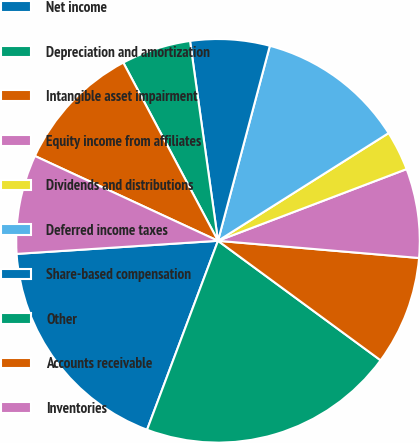<chart> <loc_0><loc_0><loc_500><loc_500><pie_chart><fcel>Net income<fcel>Depreciation and amortization<fcel>Intangible asset impairment<fcel>Equity income from affiliates<fcel>Dividends and distributions<fcel>Deferred income taxes<fcel>Share-based compensation<fcel>Other<fcel>Accounts receivable<fcel>Inventories<nl><fcel>18.25%<fcel>20.63%<fcel>8.73%<fcel>7.14%<fcel>3.18%<fcel>11.9%<fcel>6.35%<fcel>5.56%<fcel>10.32%<fcel>7.94%<nl></chart> 